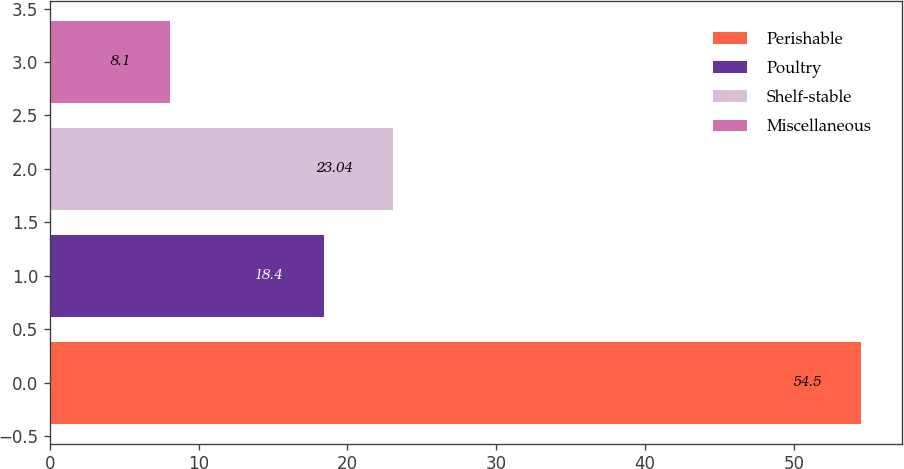Convert chart. <chart><loc_0><loc_0><loc_500><loc_500><bar_chart><fcel>Perishable<fcel>Poultry<fcel>Shelf-stable<fcel>Miscellaneous<nl><fcel>54.5<fcel>18.4<fcel>23.04<fcel>8.1<nl></chart> 